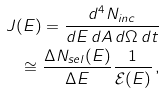Convert formula to latex. <formula><loc_0><loc_0><loc_500><loc_500>J ( E ) = \frac { d ^ { 4 } N _ { i n c } } { d E \, d A \, d \Omega \, d t } \\ \cong \frac { \Delta N _ { s e l } ( E ) } { \Delta E } \frac { 1 } { { \mathcal { E } } ( E ) } \, ,</formula> 